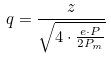<formula> <loc_0><loc_0><loc_500><loc_500>q = \frac { z } { \sqrt { 4 \cdot \frac { e \cdot P } { 2 P _ { m } } } }</formula> 